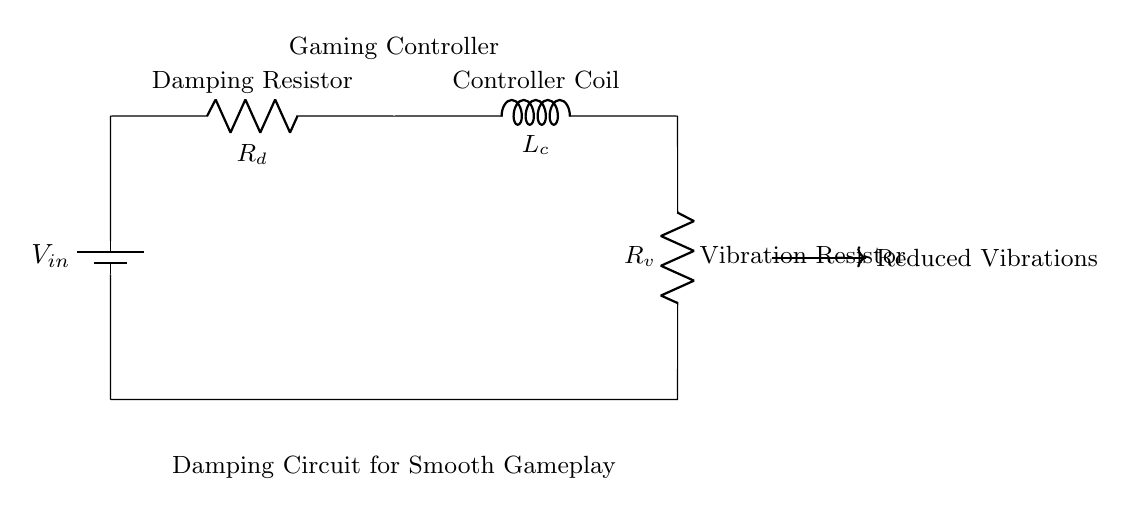What is the input voltage in this circuit? The input voltage is represented as \( V_{in} \) in the circuit diagram, which refers to the voltage provided by the battery at the top left.
Answer: V in What type of resistors are present in the circuit? The circuit contains two types of resistors: the Damping Resistor labeled \( R_d \) and the Vibration Resistor labeled \( R_v \).
Answer: Damping and Vibration Resistors How many components are connected in series? There are four main components in series in this circuit: the battery, Damping Resistor, Controller Coil (inductor), and Vibration Resistor.
Answer: Four What happens to vibrations as a result of this circuit? The circuit is designed to reduce unwanted vibrations, as indicated by the label "Reduced Vibrations" alongside an arrow pointing to the right.
Answer: Reduced Why is the Controller Coil significant in this damping circuit? The Controller Coil, labeled as \( L_c \), plays a crucial role in conjunction with the resistors to manage the current flow and thus help in damping vibrations effectively. Without the inductor, the circuit's ability to stabilize and mitigate vibrations could be compromised.
Answer: Stabilizing vibrations What is the purpose of the Damping Resistor? The Damping Resistor \( R_d \) is intended to control the current and dissipate energy, which helps in slowing down the oscillations caused by vibrations, enhancing the overall feel of gameplay.
Answer: Control current and dissipate energy 